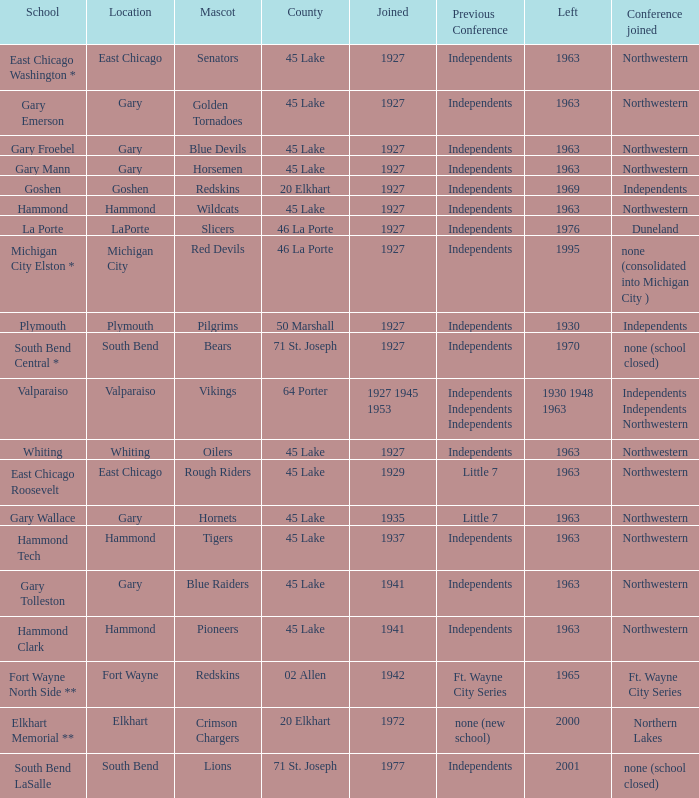Which conference held at School of whiting? Independents. 